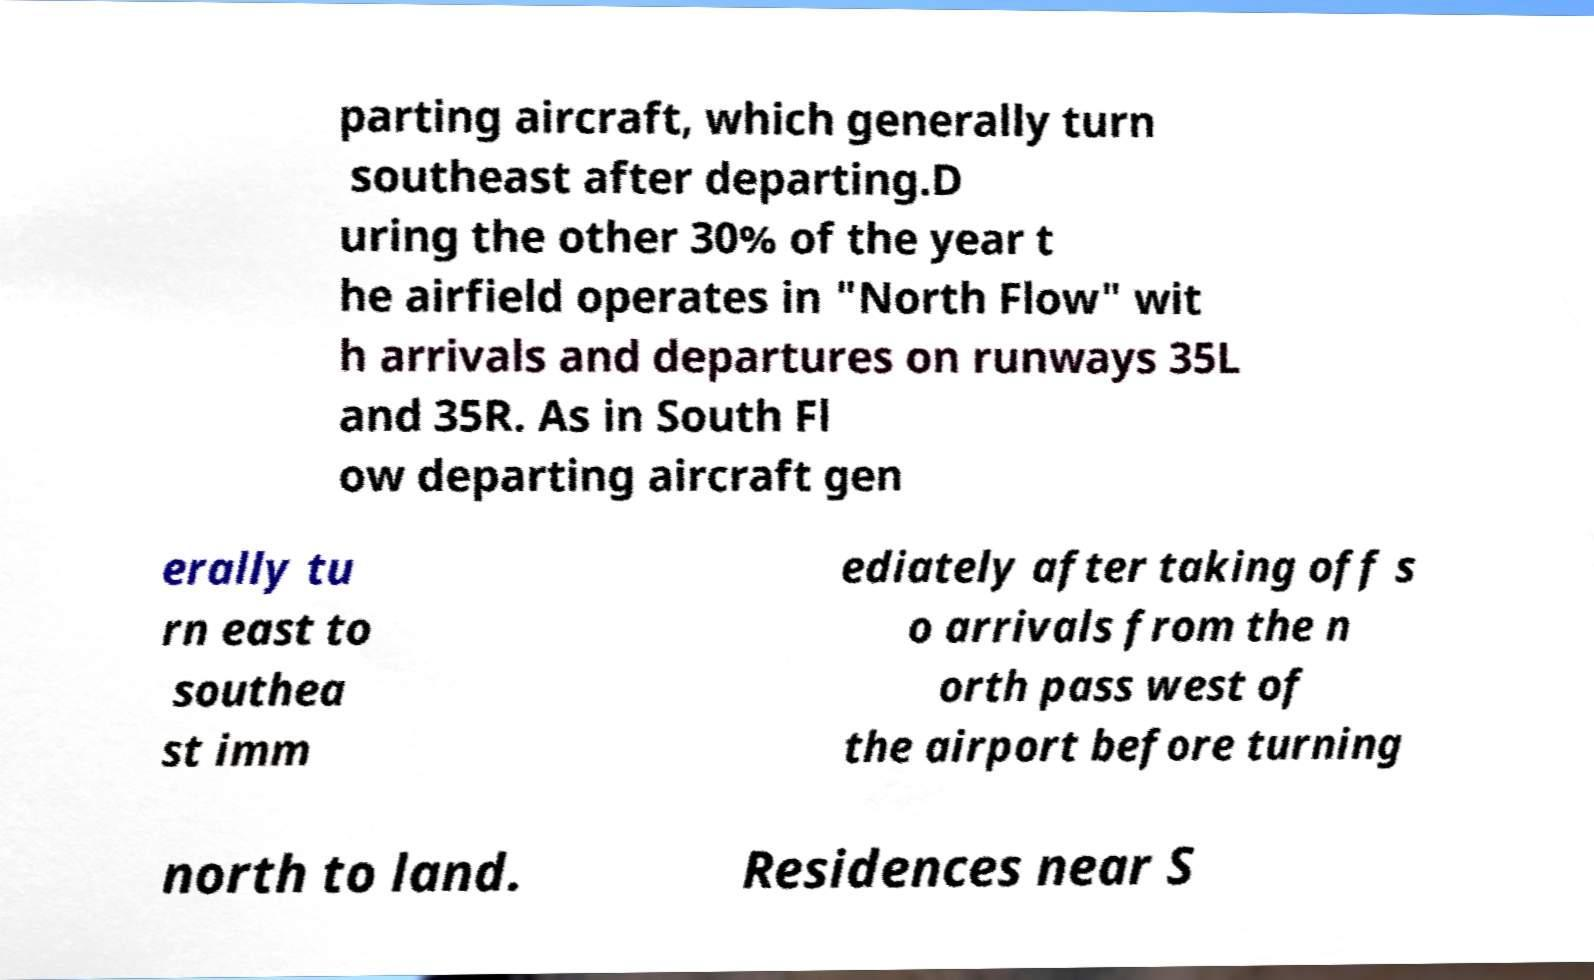For documentation purposes, I need the text within this image transcribed. Could you provide that? parting aircraft, which generally turn southeast after departing.D uring the other 30% of the year t he airfield operates in "North Flow" wit h arrivals and departures on runways 35L and 35R. As in South Fl ow departing aircraft gen erally tu rn east to southea st imm ediately after taking off s o arrivals from the n orth pass west of the airport before turning north to land. Residences near S 